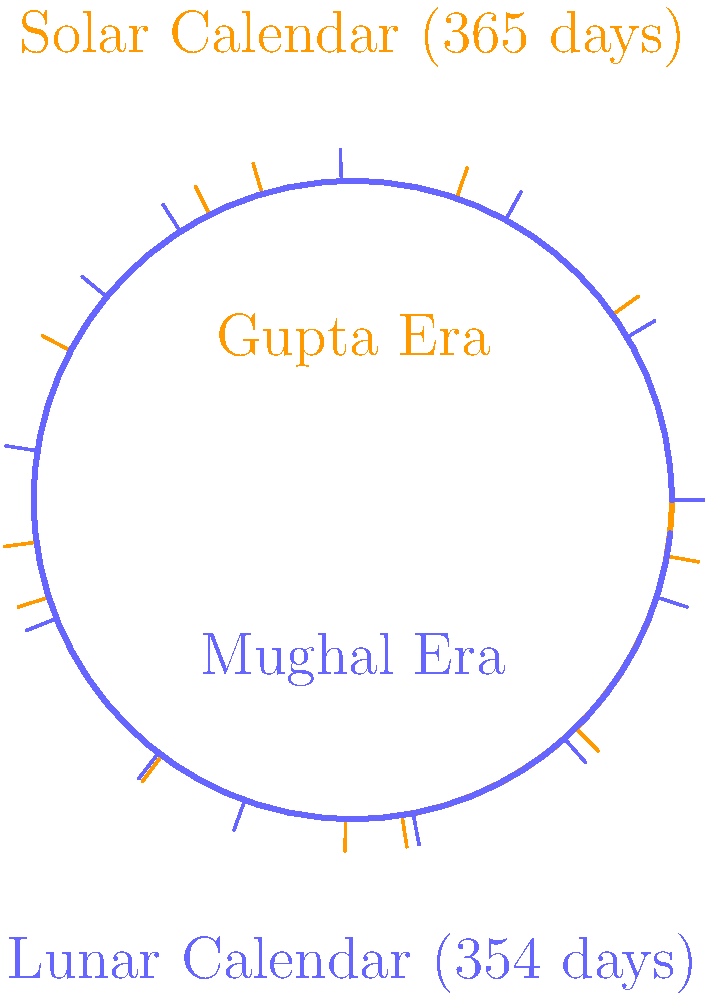During the transition from the Gupta Empire to the Mughal Empire, there was a shift in the primary calendar system used in India. Which calendar system was predominantly used during the Gupta Era, and how did it differ from the one adopted during the Mughal period? To answer this question, let's examine the historical context and calendar systems:

1. Gupta Era (320-550 CE):
   - The Gupta Empire primarily used a solar calendar system.
   - This calendar was based on the movement of the Sun and had approximately 365 days per year.
   - It was closely aligned with agricultural seasons and Hindu festivals.

2. Mughal Era (1526-1857 CE):
   - The Mughal Empire, being Islamic in origin, adopted a lunar calendar system.
   - The Islamic lunar calendar has approximately 354 days per year.
   - It is based on the cycles of the moon's phases.

3. Key differences:
   - The solar calendar (Gupta Era) has about 11 more days than the lunar calendar (Mughal Era).
   - Solar calendars maintain consistency with seasons, while lunar calendars drift through the seasons over time.
   - The solar calendar was more suitable for agricultural purposes, while the lunar calendar was used for religious observances in Islam.

4. Transition:
   - The shift from solar to lunar calendar occurred gradually with the establishment of Muslim rule in India.
   - However, both systems continued to coexist, with the solar calendar still used for agricultural and some administrative purposes.

5. Impact:
   - This calendar shift reflects the cultural and religious changes that occurred with the transition of power from Hindu to Muslim rulers in India.
   - It also demonstrates the complex interplay between astronomy, religion, and governance in Indian history.
Answer: Solar calendar (Gupta); Lunar calendar (Mughal); 11-day difference 